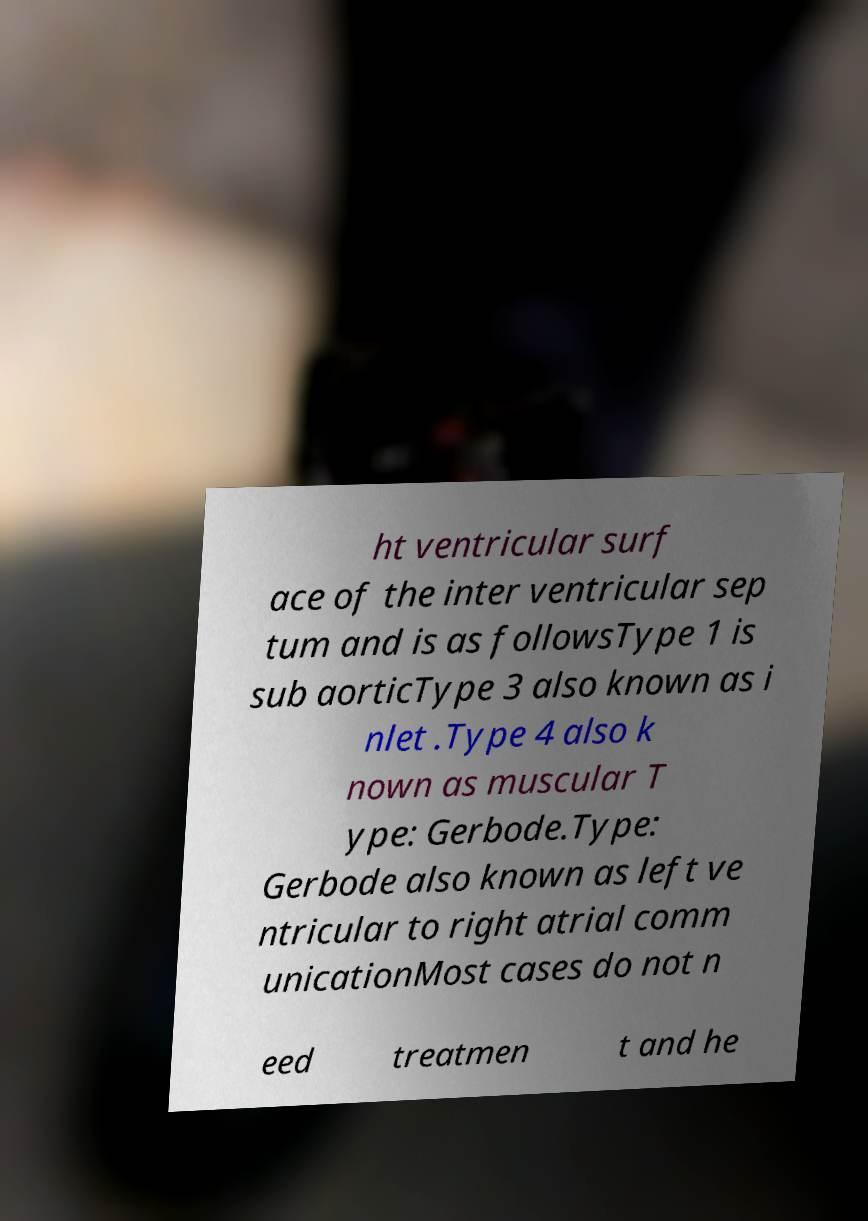There's text embedded in this image that I need extracted. Can you transcribe it verbatim? ht ventricular surf ace of the inter ventricular sep tum and is as followsType 1 is sub aorticType 3 also known as i nlet .Type 4 also k nown as muscular T ype: Gerbode.Type: Gerbode also known as left ve ntricular to right atrial comm unicationMost cases do not n eed treatmen t and he 